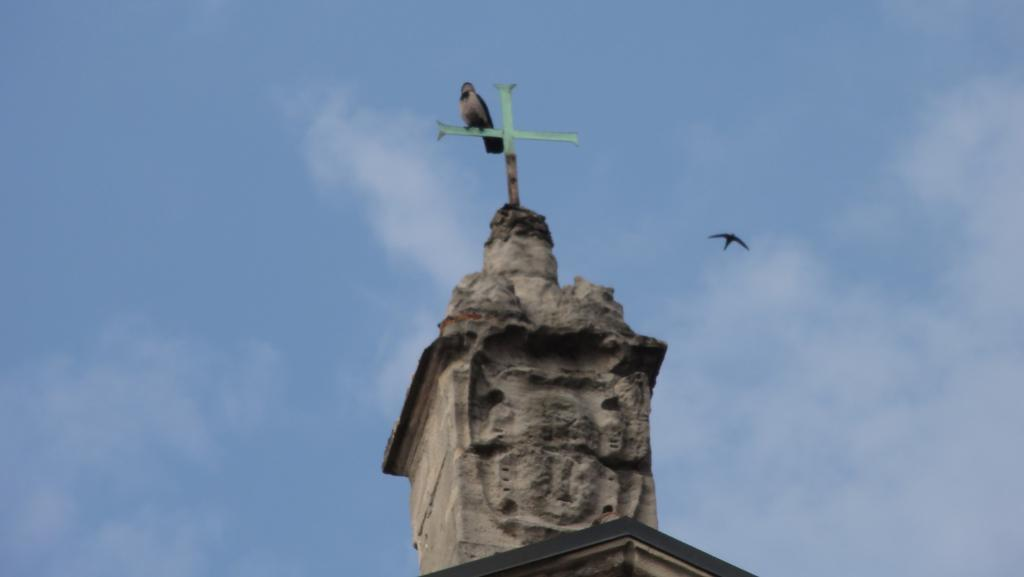What is the main subject in the middle of the image? There is a statue in the middle of the image. Is there anything on the statue? Yes, there is a bird on the statue. What can be seen in the sky in the image? There are clouds in the sky, and the sky is visible in the image. Can you describe any other bird-related activity in the image? Yes, there is a bird flying in the image. What type of humor can be seen in the image? There is no humor present in the image; it features a statue with a bird on it and clouds in the sky. 